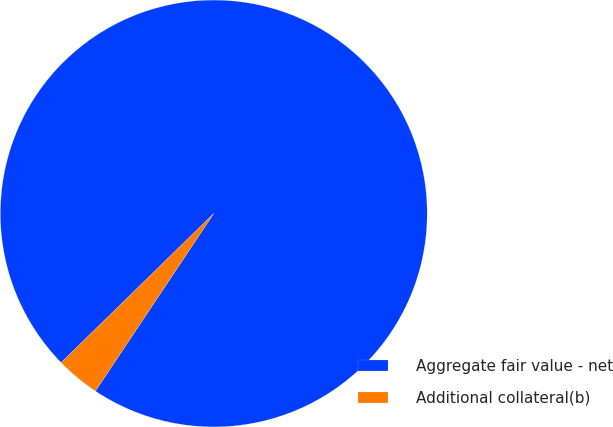Convert chart to OTSL. <chart><loc_0><loc_0><loc_500><loc_500><pie_chart><fcel>Aggregate fair value - net<fcel>Additional collateral(b)<nl><fcel>96.67%<fcel>3.33%<nl></chart> 